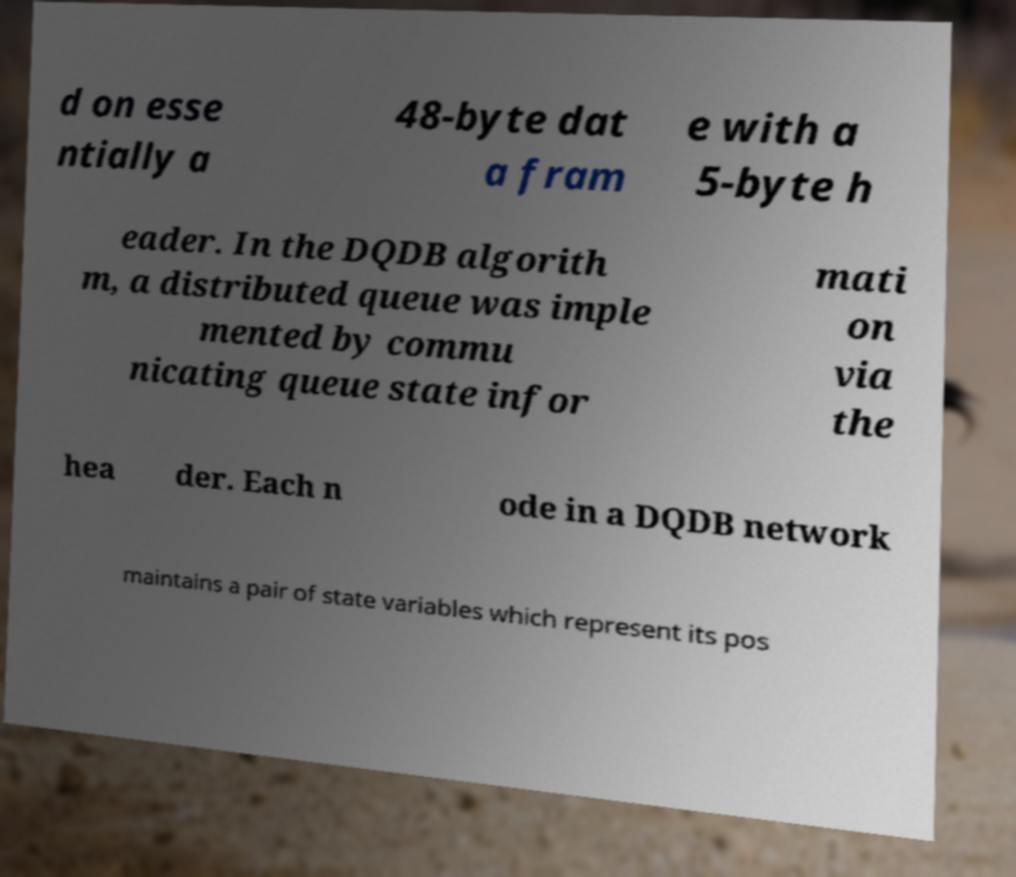Could you assist in decoding the text presented in this image and type it out clearly? d on esse ntially a 48-byte dat a fram e with a 5-byte h eader. In the DQDB algorith m, a distributed queue was imple mented by commu nicating queue state infor mati on via the hea der. Each n ode in a DQDB network maintains a pair of state variables which represent its pos 